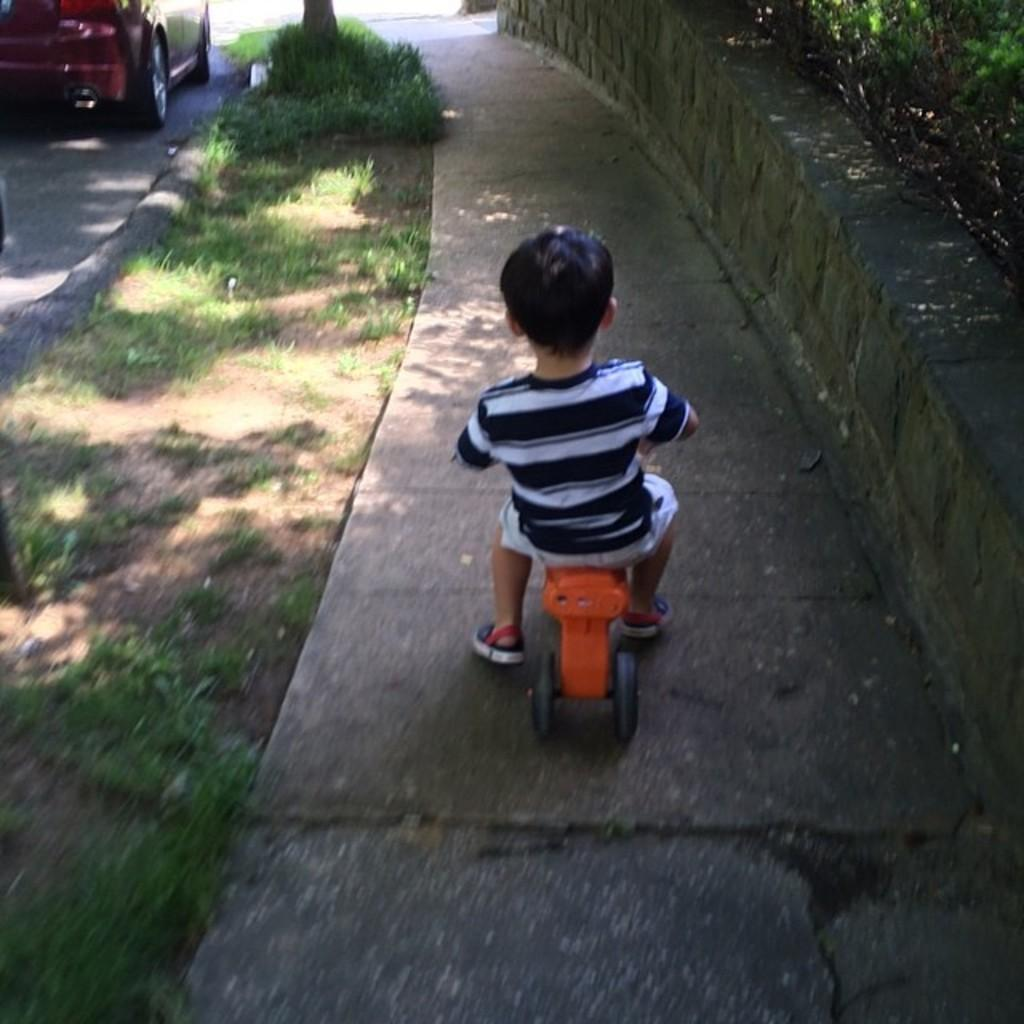What is the kid doing in the image? The kid is riding a bicycle in the image. Where is the kid riding the bicycle? The kid is on a walkway. What else can be seen in the image besides the kid on the bicycle? There is a car parked in the image and plants on the right side of the image. How many kittens are sitting on the handlebars of the bicycle in the image? There are no kittens present in the image, so it is not possible to determine the number of kittens on the handlebars. 